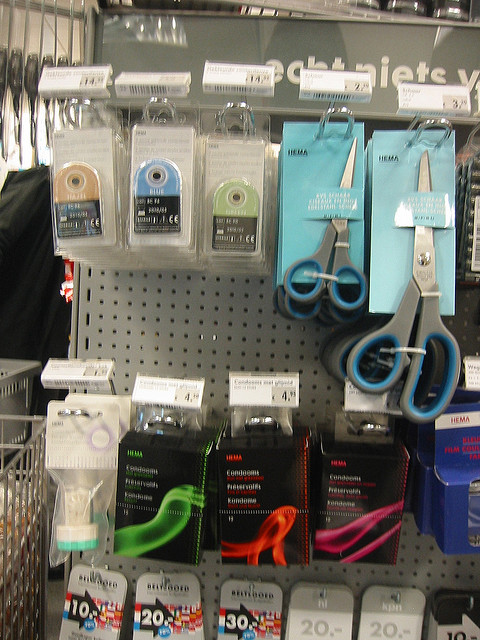Please identify all text content in this image. iell V 20 20 10 20 30 